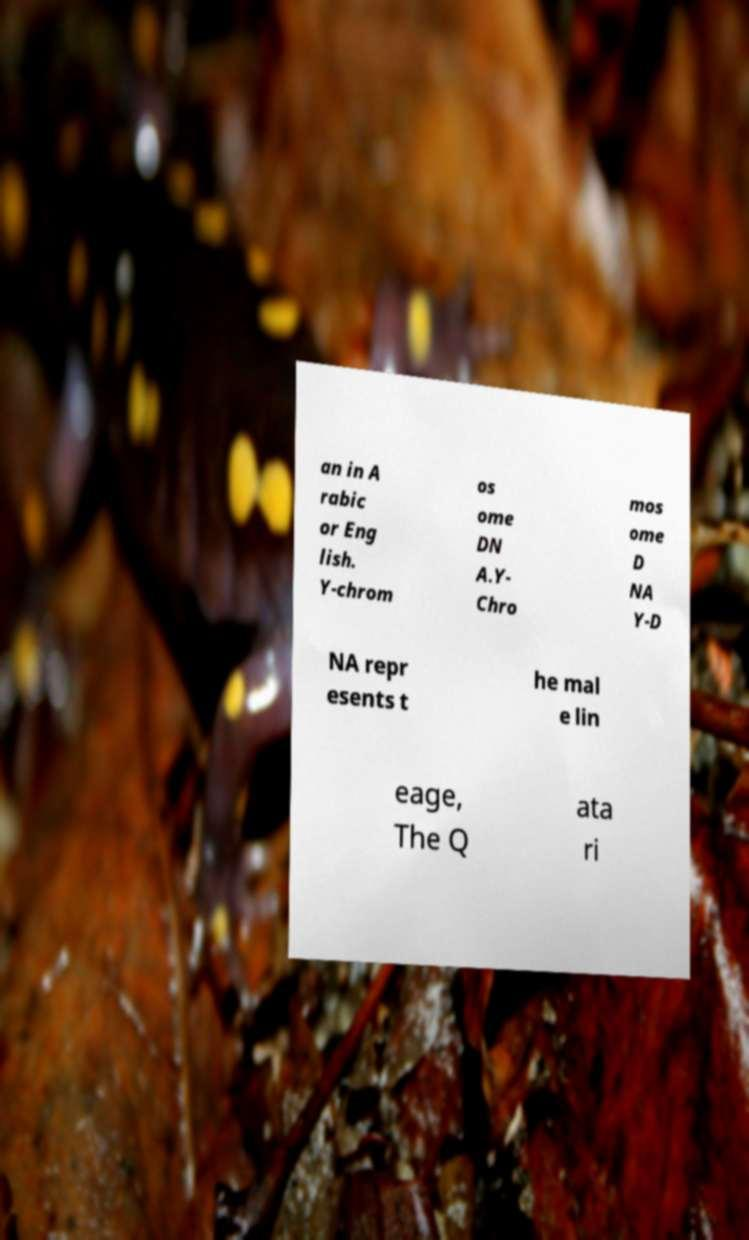I need the written content from this picture converted into text. Can you do that? an in A rabic or Eng lish. Y-chrom os ome DN A.Y- Chro mos ome D NA Y-D NA repr esents t he mal e lin eage, The Q ata ri 